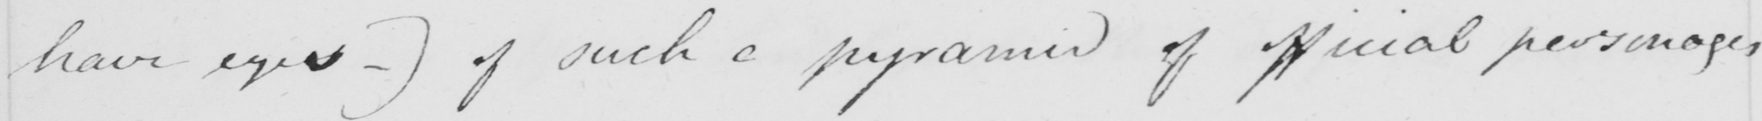What text is written in this handwritten line? have eyes  _  )  of such a pyramid of official personages 